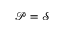<formula> <loc_0><loc_0><loc_500><loc_500>\mathcal { P } = \mathcal { S }</formula> 